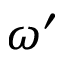Convert formula to latex. <formula><loc_0><loc_0><loc_500><loc_500>\omega ^ { \prime }</formula> 